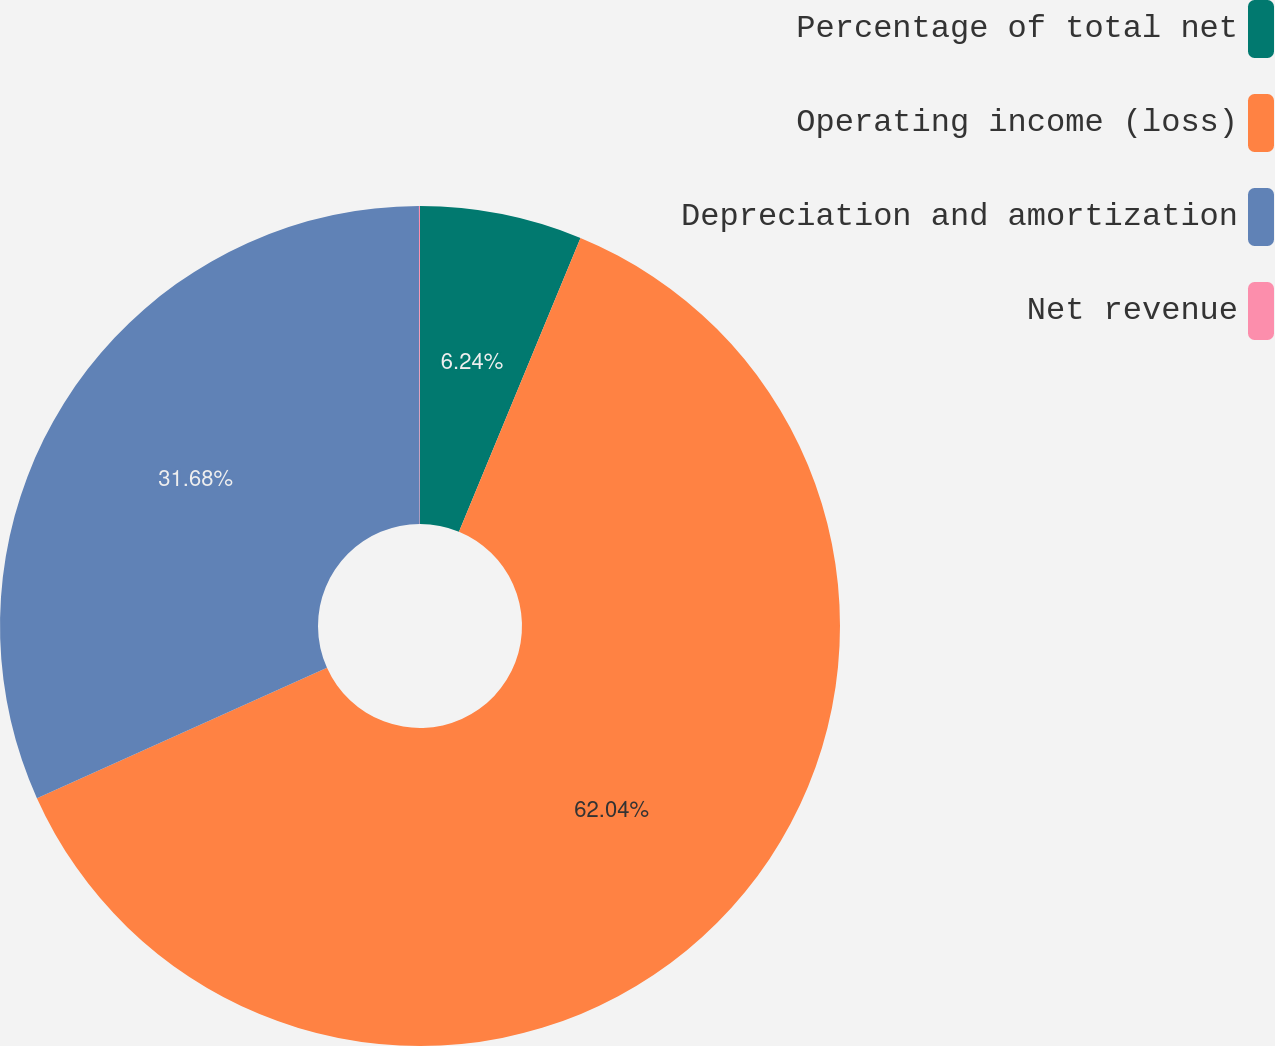<chart> <loc_0><loc_0><loc_500><loc_500><pie_chart><fcel>Percentage of total net<fcel>Operating income (loss)<fcel>Depreciation and amortization<fcel>Net revenue<nl><fcel>6.24%<fcel>62.03%<fcel>31.68%<fcel>0.04%<nl></chart> 